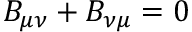<formula> <loc_0><loc_0><loc_500><loc_500>B _ { \mu \nu } + B _ { \nu \mu } = 0</formula> 